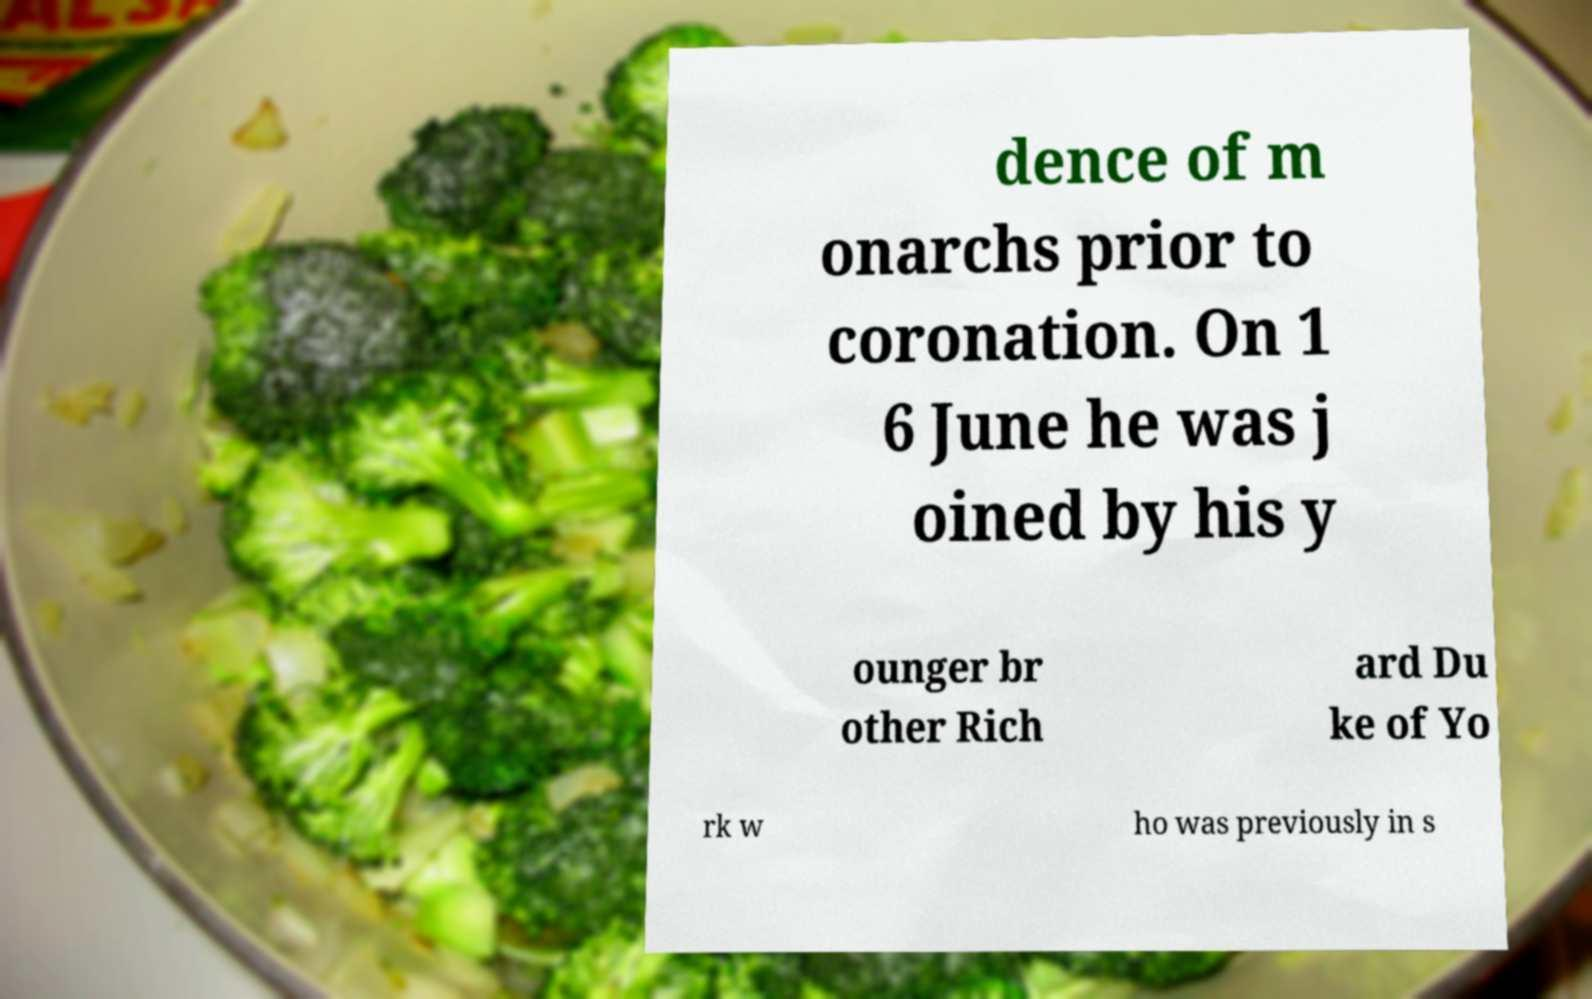For documentation purposes, I need the text within this image transcribed. Could you provide that? dence of m onarchs prior to coronation. On 1 6 June he was j oined by his y ounger br other Rich ard Du ke of Yo rk w ho was previously in s 